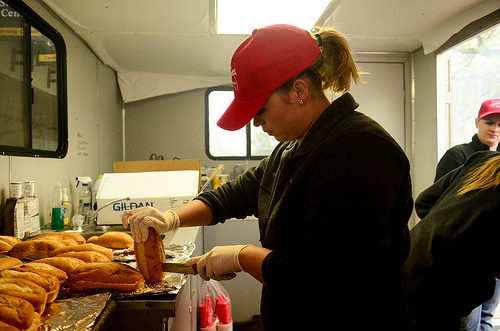<image>
Is there a girl behind the bread? Yes. From this viewpoint, the girl is positioned behind the bread, with the bread partially or fully occluding the girl. 